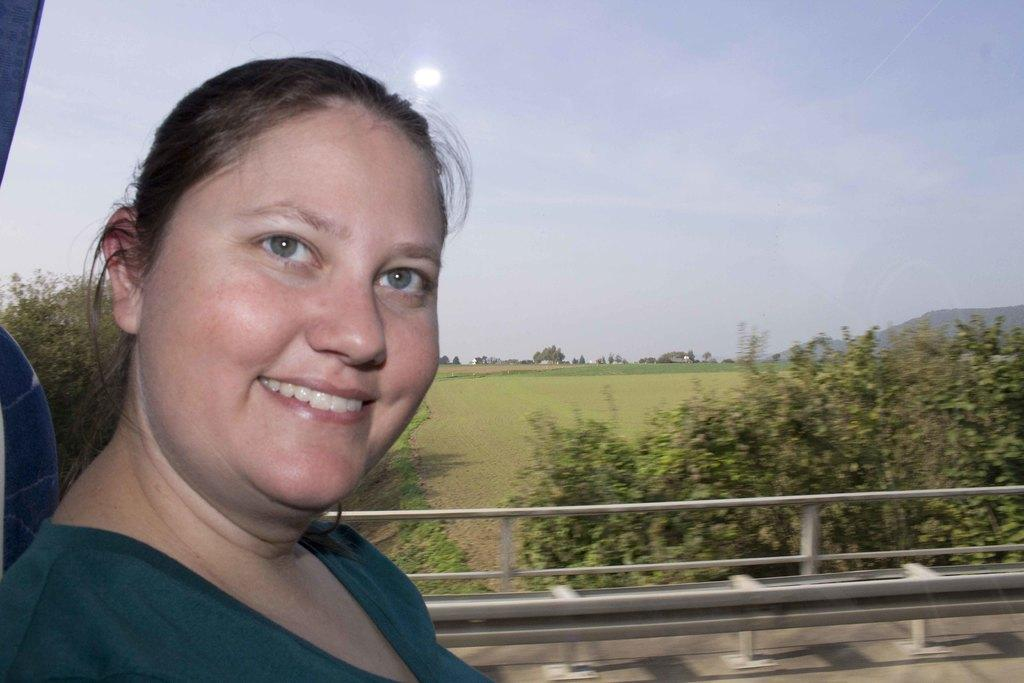What is the main subject in the foreground of the picture? There is a woman in the foreground of the picture. What is the woman doing in the picture? The woman is sitting. What is the expression on the woman's face? The woman has a smile on her face. What can be seen through the glass in the background? There is a background visible through a glass, which includes plants, grass, trees, a mountain, and the sky. What type of cookware can be seen in the woman's hand in the image? There is no cookware present in the image; the woman is sitting and smiling. What type of rake is being used to maintain the grass in the background? There is no rake visible in the image; the grass is part of the natural background. 